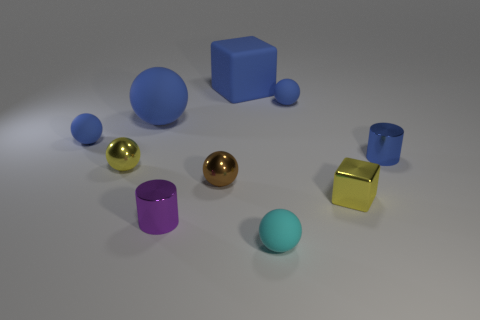What is the material of the blue thing that is in front of the large blue sphere and to the right of the cyan ball?
Offer a very short reply. Metal. There is a blue metallic thing; does it have the same size as the ball that is on the right side of the tiny cyan rubber ball?
Your response must be concise. Yes. Are any big red objects visible?
Your response must be concise. No. What material is the other object that is the same shape as the small purple metal thing?
Provide a succinct answer. Metal. What is the size of the yellow object that is on the right side of the small matte object in front of the metal cylinder to the right of the yellow metal block?
Your response must be concise. Small. Are there any blue metal objects on the right side of the tiny blue shiny cylinder?
Your response must be concise. No. What size is the yellow ball that is made of the same material as the small brown sphere?
Make the answer very short. Small. How many tiny blue things are the same shape as the cyan object?
Keep it short and to the point. 2. Does the big sphere have the same material as the cylinder to the right of the cyan thing?
Your response must be concise. No. Are there more blue spheres that are left of the blue shiny cylinder than small metal blocks?
Offer a terse response. Yes. 